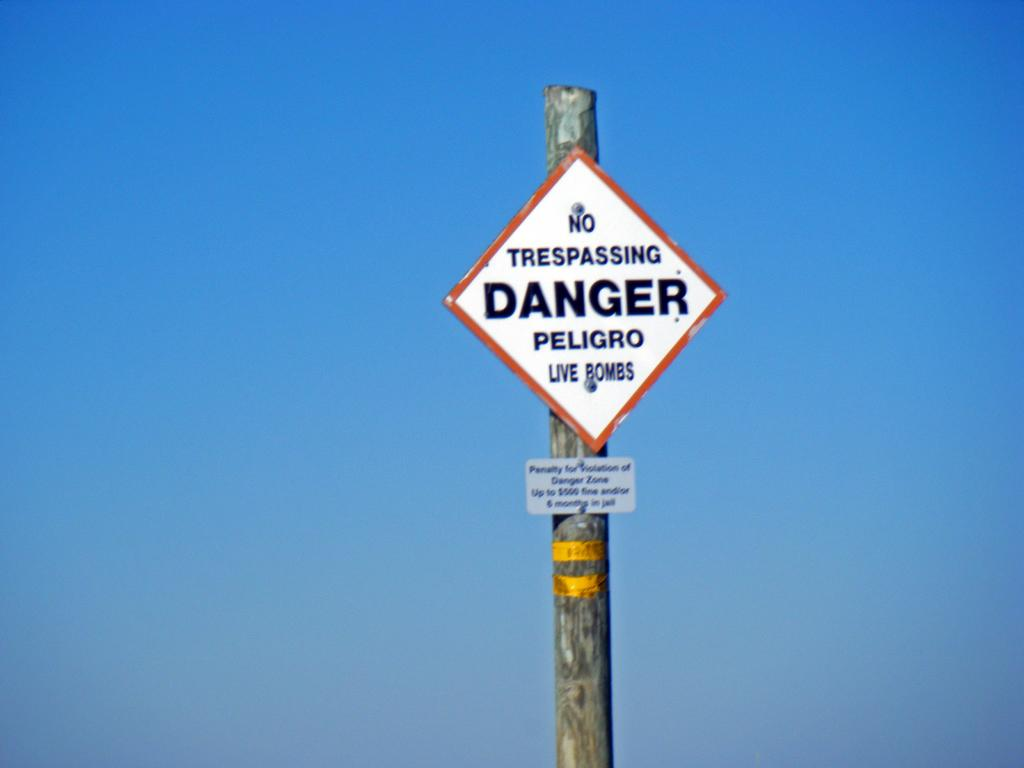<image>
Give a short and clear explanation of the subsequent image. A no trespassing sign says that there is danger from bombs. 